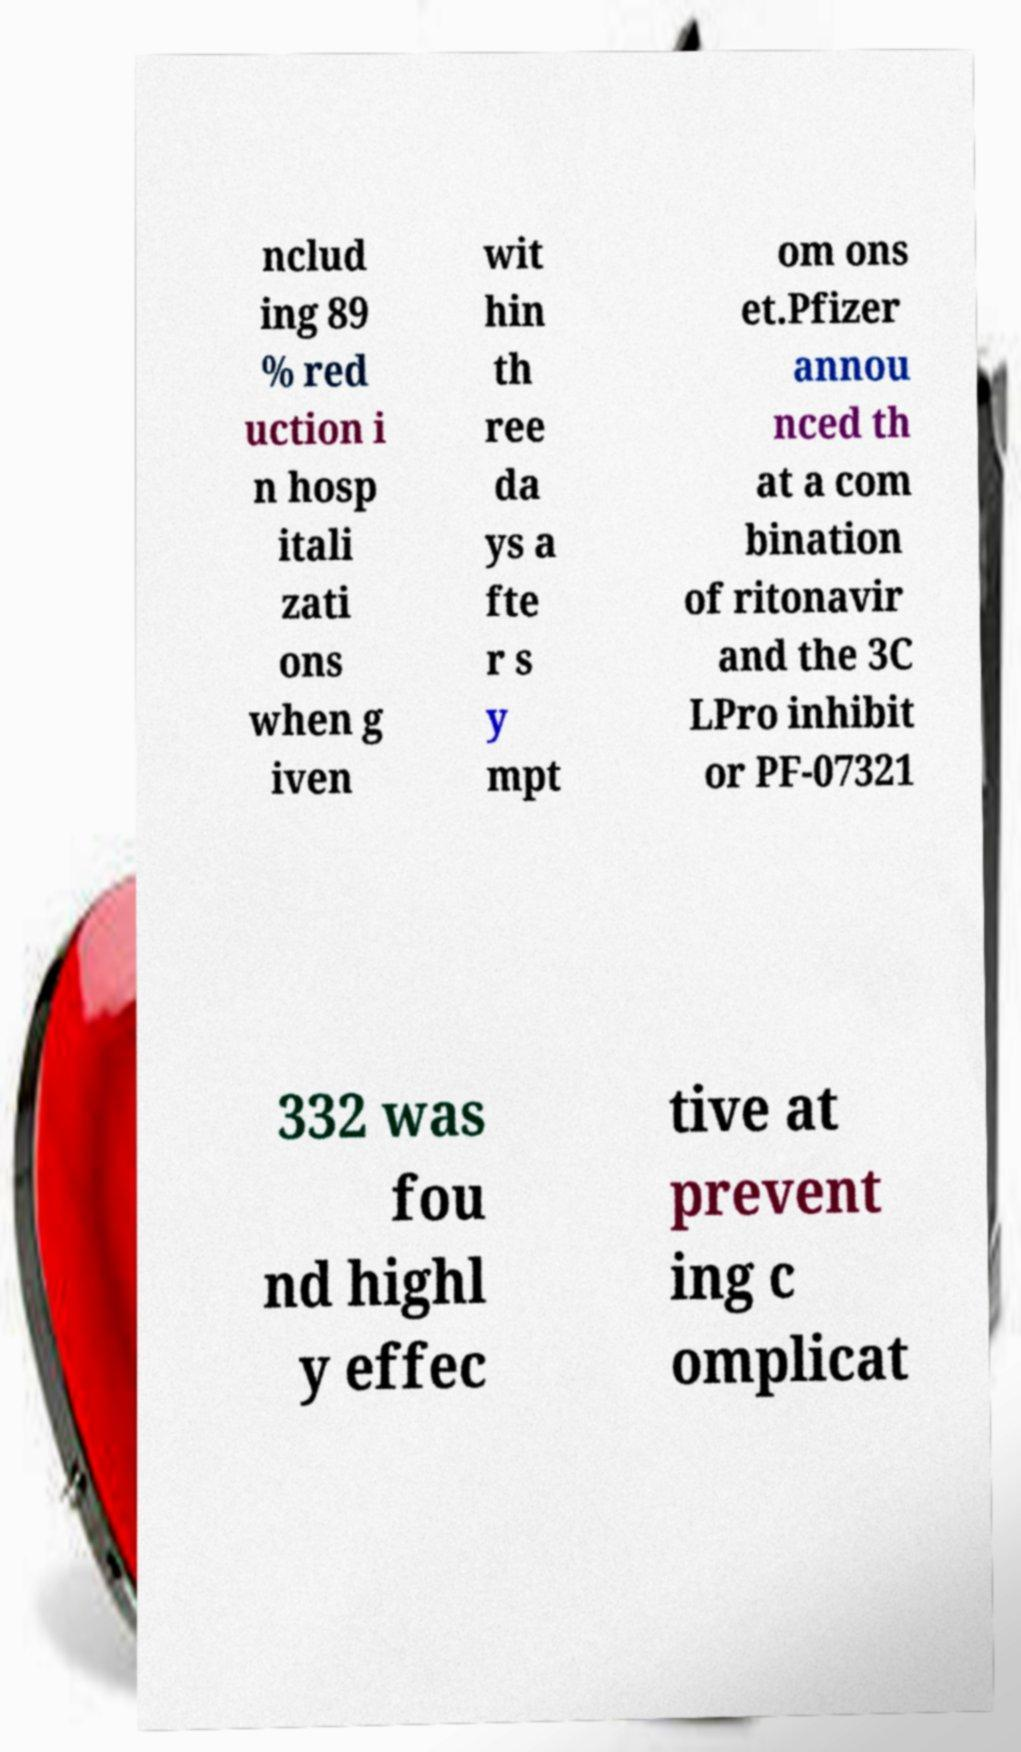Could you assist in decoding the text presented in this image and type it out clearly? nclud ing 89 % red uction i n hosp itali zati ons when g iven wit hin th ree da ys a fte r s y mpt om ons et.Pfizer annou nced th at a com bination of ritonavir and the 3C LPro inhibit or PF-07321 332 was fou nd highl y effec tive at prevent ing c omplicat 